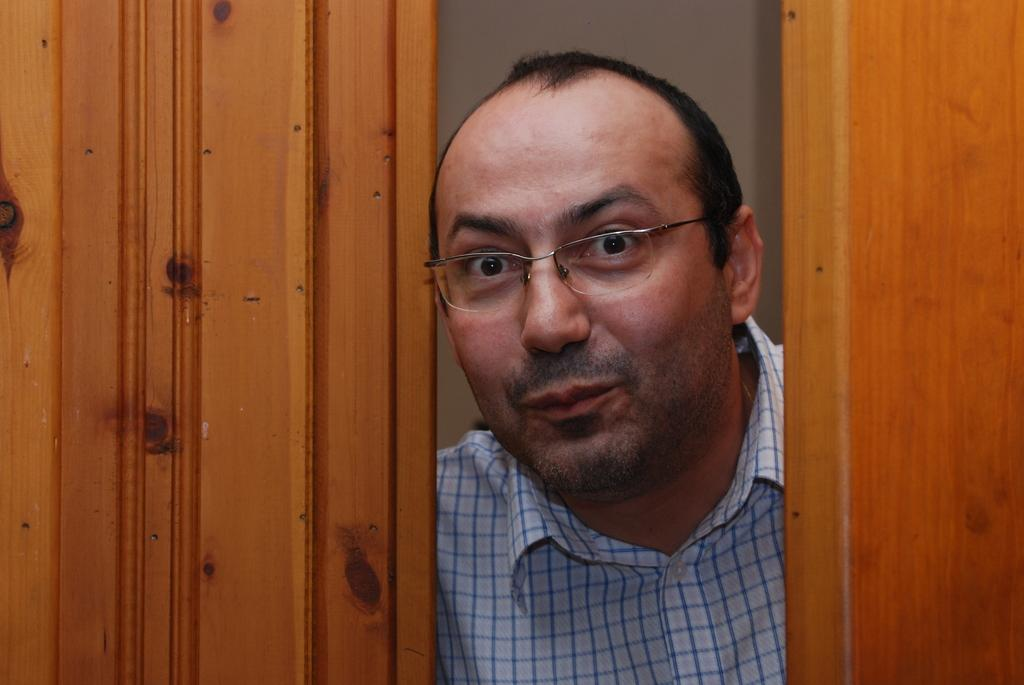Who is present in the image? There is a man in the image. What is the man wearing in the image? The man is wearing spectacles in the image. What can be seen behind the man in the image? There is a white object that looks like a wall behind the man. What type of objects are on the sides of the image? There are two wooden objects that look like doors on the right and left sides of the image. What type of flesh can be seen on the man's face in the image? There is no mention of flesh or any specific facial features in the provided facts, so we cannot determine what type of flesh might be visible on the man's face. 